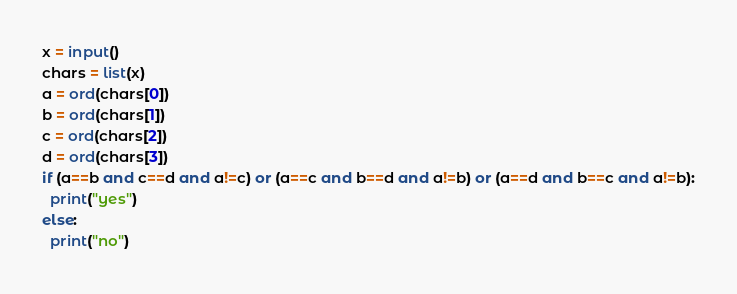<code> <loc_0><loc_0><loc_500><loc_500><_Python_>x = input()
chars = list(x)
a = ord(chars[0])
b = ord(chars[1])
c = ord(chars[2])
d = ord(chars[3])
if (a==b and c==d and a!=c) or (a==c and b==d and a!=b) or (a==d and b==c and a!=b):
  print("yes")
else:
  print("no")

</code> 